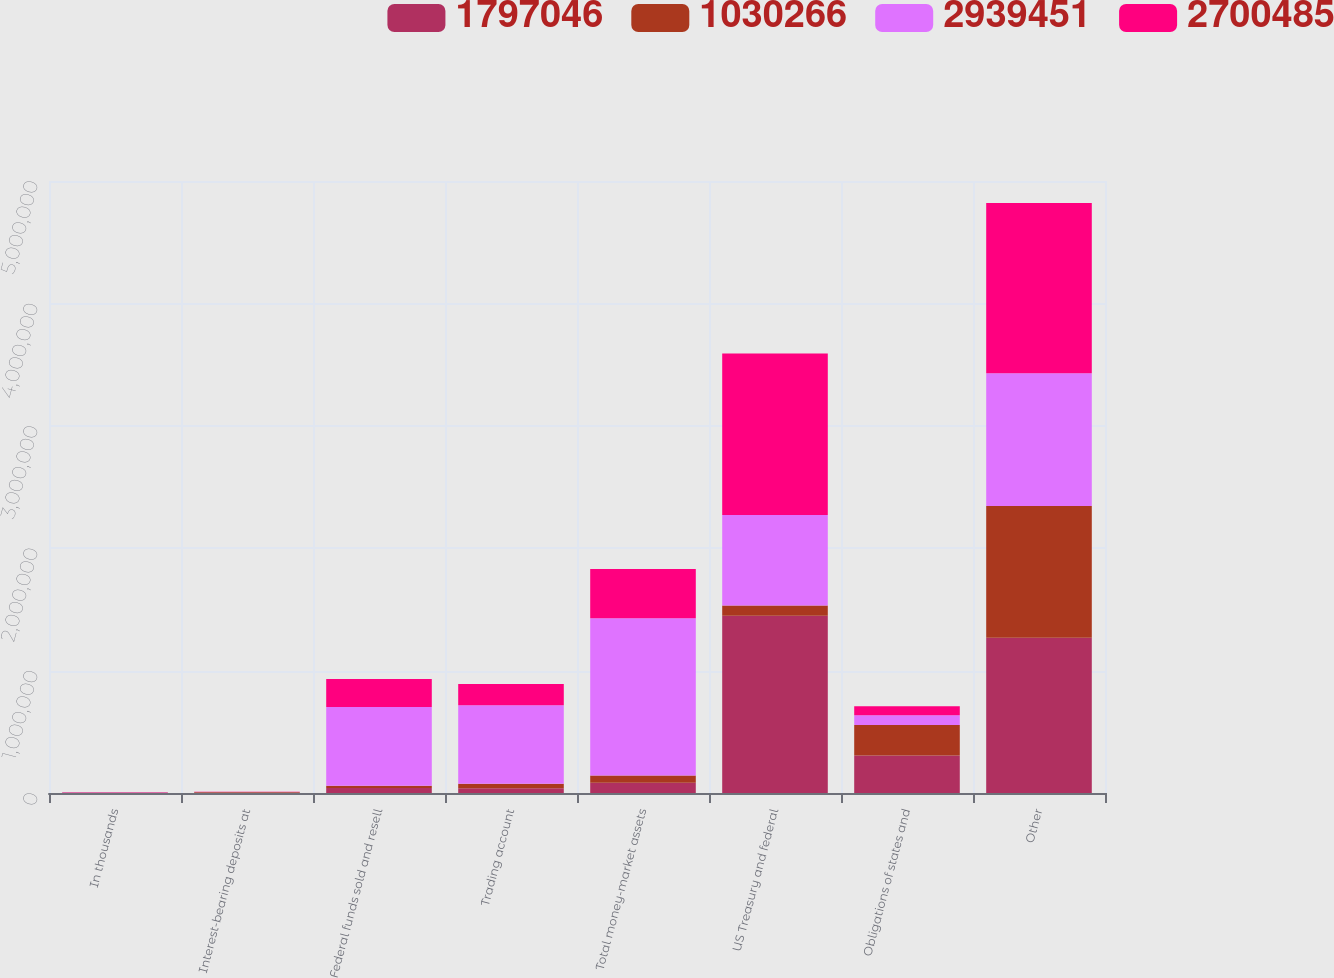Convert chart to OTSL. <chart><loc_0><loc_0><loc_500><loc_500><stacked_bar_chart><ecel><fcel>In thousands<fcel>Interest-bearing deposits at<fcel>Federal funds sold and resell<fcel>Trading account<fcel>Total money-market assets<fcel>US Treasury and federal<fcel>Obligations of states and<fcel>Other<nl><fcel>1.79705e+06<fcel>2001<fcel>4341<fcel>41086<fcel>38929<fcel>84356<fcel>1.4484e+06<fcel>306768<fcel>1.26897e+06<nl><fcel>1.03027e+06<fcel>2000<fcel>3102<fcel>17261<fcel>37431<fcel>57794<fcel>84356<fcel>249425<fcel>1.07608e+06<nl><fcel>2.93945e+06<fcel>1999<fcel>1092<fcel>643555<fcel>641114<fcel>1.28576e+06<fcel>737586<fcel>79189<fcel>1.08375e+06<nl><fcel>2.70048e+06<fcel>1998<fcel>674<fcel>229066<fcel>173122<fcel>402862<fcel>1.321e+06<fcel>73789<fcel>1.39078e+06<nl></chart> 